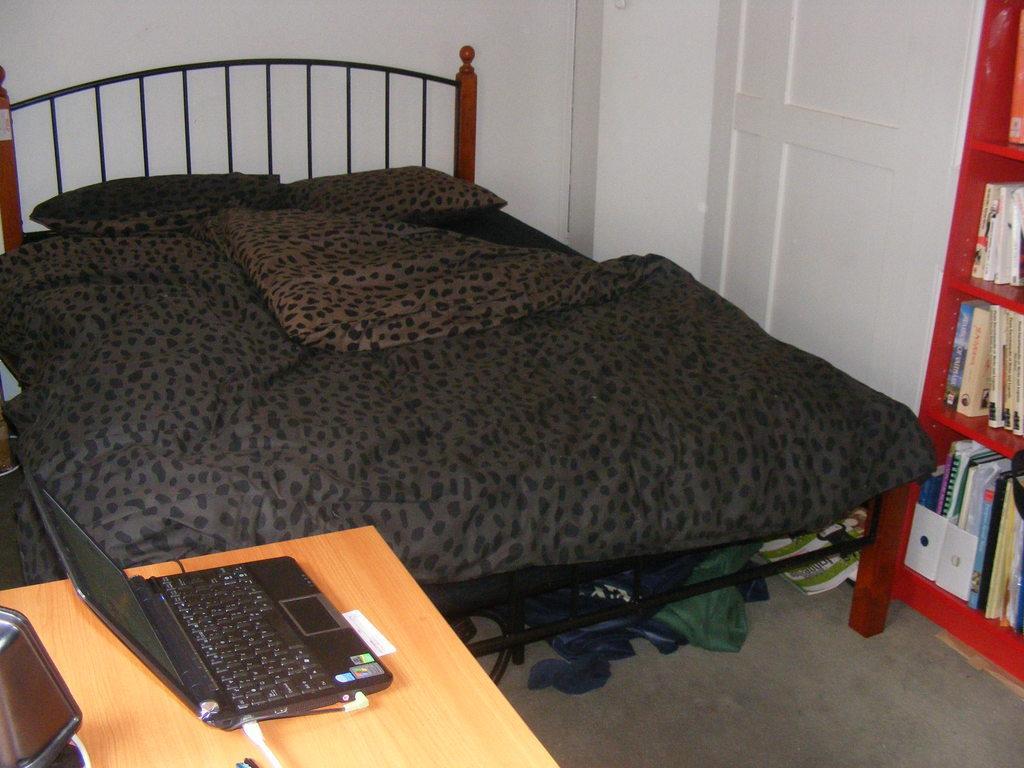How would you summarize this image in a sentence or two? It is a bedroom the bed is of brown color and a brown and black bed sheet in front of the bed there is a table and a laptop over it to the right side of the bed there is a bookshelf with lot of books in the background there is a white color wall. 